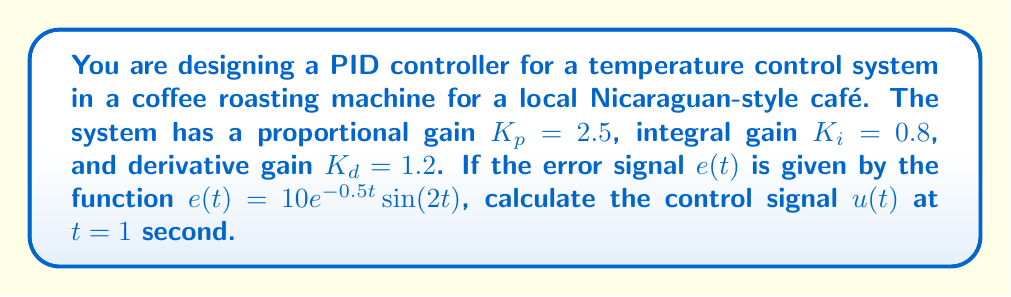Provide a solution to this math problem. To solve this problem, we'll follow these steps:

1) The general form of a PID controller is:

   $$u(t) = K_p e(t) + K_i \int_0^t e(\tau) d\tau + K_d \frac{de(t)}{dt}$$

2) We're given $K_p = 2.5$, $K_i = 0.8$, and $K_d = 1.2$.

3) The error signal is $e(t) = 10e^{-0.5t}\sin(2t)$.

4) We need to calculate each term of the PID controller at $t = 1$:

   a) Proportional term: $K_p e(t)$
      At $t = 1$: $2.5 \cdot 10e^{-0.5}\sin(2) = 15.17$

   b) Integral term: $K_i \int_0^t e(\tau) d\tau$
      We need to integrate $10e^{-0.5\tau}\sin(2\tau)$ from 0 to 1:
      $$\int_0^1 10e^{-0.5\tau}\sin(2\tau) d\tau = 3.46$$
      So the integral term is: $0.8 \cdot 3.46 = 2.77$

   c) Derivative term: $K_d \frac{de(t)}{dt}$
      $\frac{de(t)}{dt} = 10e^{-0.5t}(-0.5\sin(2t) + 2\cos(2t))$
      At $t = 1$: $10e^{-0.5}(-0.5\sin(2) + 2\cos(2)) = 5.02$
      So the derivative term is: $1.2 \cdot 5.02 = 6.02$

5) Sum all terms: $15.17 + 2.77 + 6.02 = 23.96$
Answer: $u(1) = 23.96$ 